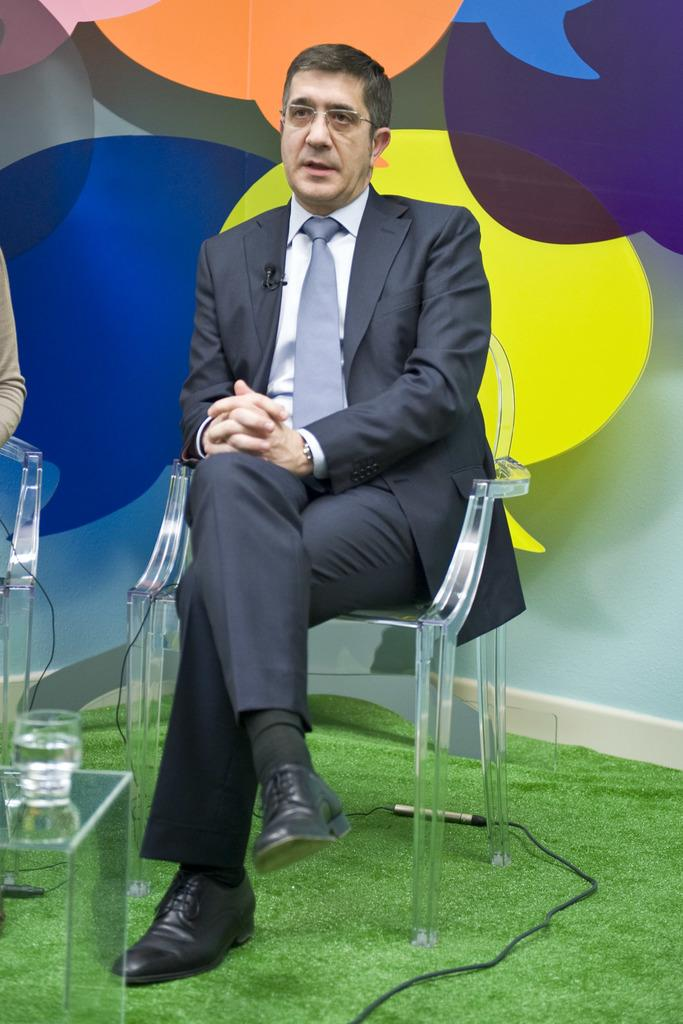Who is present in the image? There is a man in the image. What is the man doing in the image? The man is sitting on a chair. Can you describe the background of the image? The background of the image is colorful. What type of pollution can be seen in the image? There is no pollution present in the image. Is the man wearing a sweater in the image? The provided facts do not mention the man's clothing, so we cannot determine if he is wearing a sweater. 